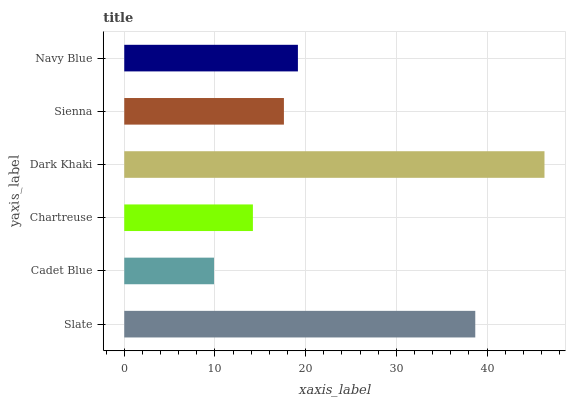Is Cadet Blue the minimum?
Answer yes or no. Yes. Is Dark Khaki the maximum?
Answer yes or no. Yes. Is Chartreuse the minimum?
Answer yes or no. No. Is Chartreuse the maximum?
Answer yes or no. No. Is Chartreuse greater than Cadet Blue?
Answer yes or no. Yes. Is Cadet Blue less than Chartreuse?
Answer yes or no. Yes. Is Cadet Blue greater than Chartreuse?
Answer yes or no. No. Is Chartreuse less than Cadet Blue?
Answer yes or no. No. Is Navy Blue the high median?
Answer yes or no. Yes. Is Sienna the low median?
Answer yes or no. Yes. Is Dark Khaki the high median?
Answer yes or no. No. Is Navy Blue the low median?
Answer yes or no. No. 